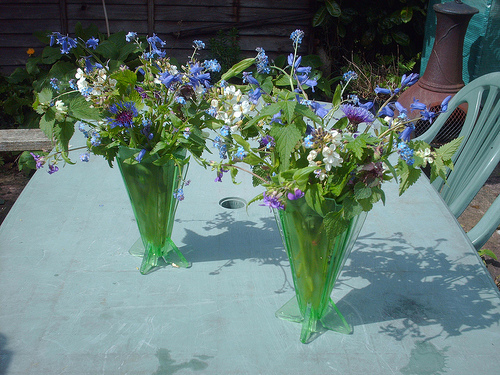Please provide a short description for this region: [0.79, 0.13, 0.95, 0.44]. Within this region stands a distinctive round, red fire box for outdoor use, featuring a cylindrical shape and partially visible metal stands. 